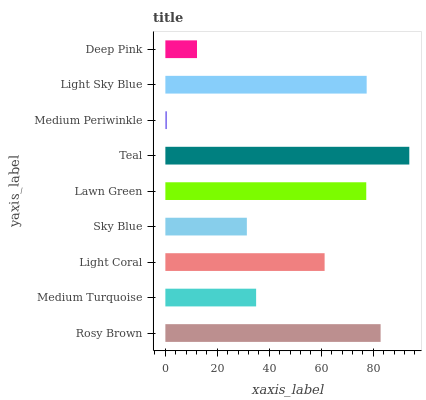Is Medium Periwinkle the minimum?
Answer yes or no. Yes. Is Teal the maximum?
Answer yes or no. Yes. Is Medium Turquoise the minimum?
Answer yes or no. No. Is Medium Turquoise the maximum?
Answer yes or no. No. Is Rosy Brown greater than Medium Turquoise?
Answer yes or no. Yes. Is Medium Turquoise less than Rosy Brown?
Answer yes or no. Yes. Is Medium Turquoise greater than Rosy Brown?
Answer yes or no. No. Is Rosy Brown less than Medium Turquoise?
Answer yes or no. No. Is Light Coral the high median?
Answer yes or no. Yes. Is Light Coral the low median?
Answer yes or no. Yes. Is Sky Blue the high median?
Answer yes or no. No. Is Rosy Brown the low median?
Answer yes or no. No. 